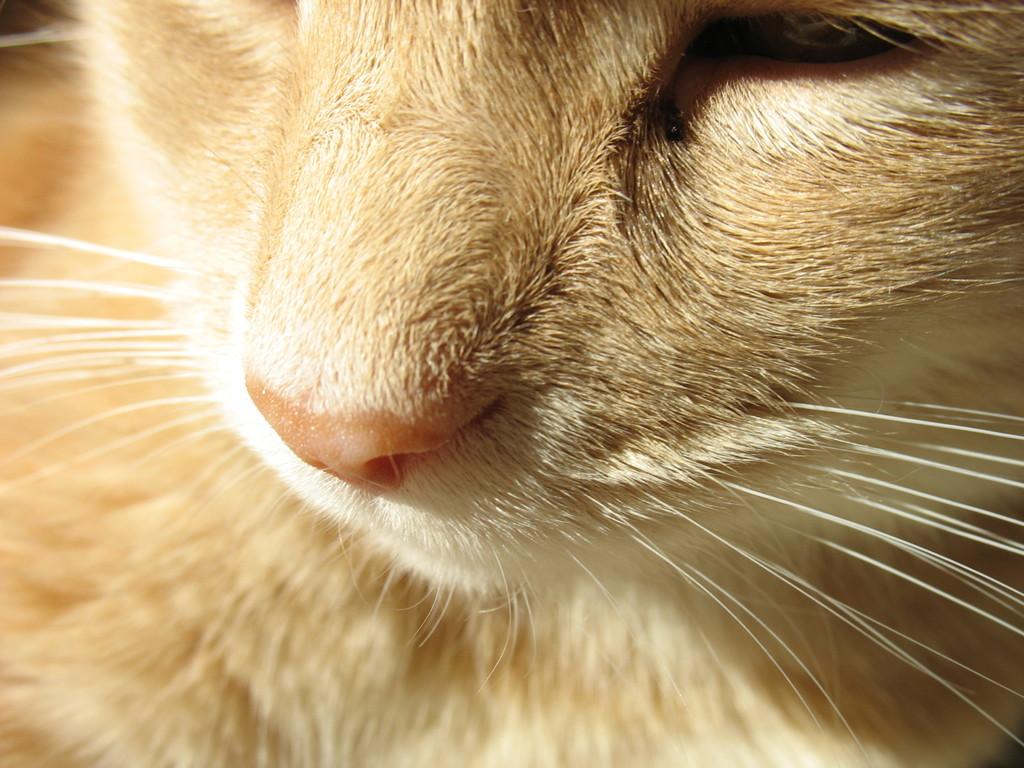What type of living creature is present in the image? There is an animal in the image. What type of music is the band playing in the image? There is no band present in the image, so it is not possible to determine what type of music they might be playing. 